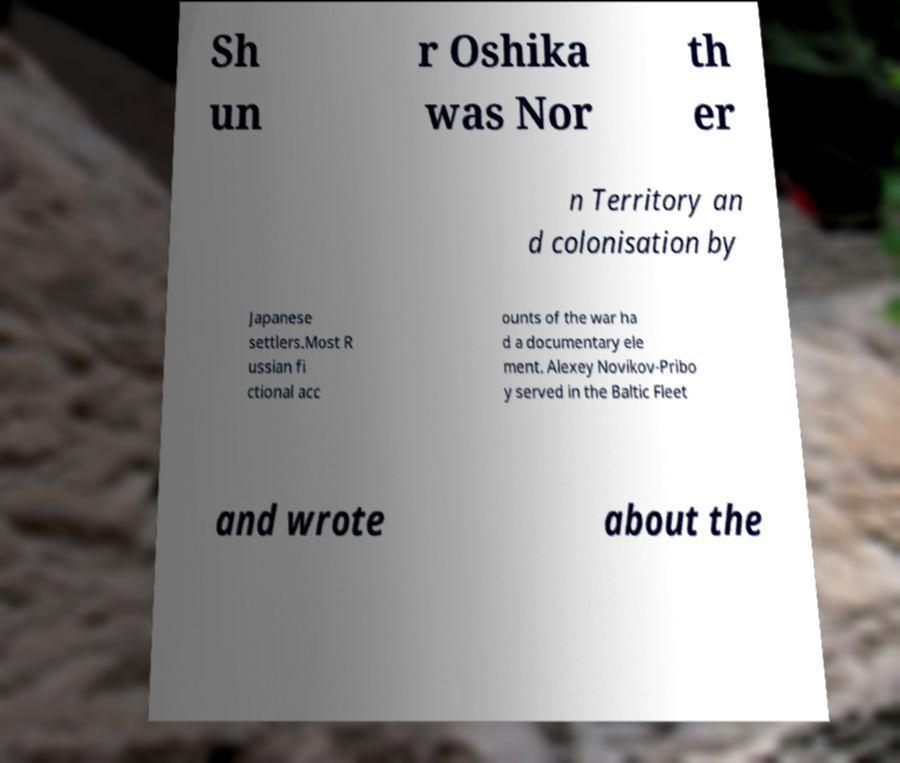Could you assist in decoding the text presented in this image and type it out clearly? Sh un r Oshika was Nor th er n Territory an d colonisation by Japanese settlers.Most R ussian fi ctional acc ounts of the war ha d a documentary ele ment. Alexey Novikov-Pribo y served in the Baltic Fleet and wrote about the 